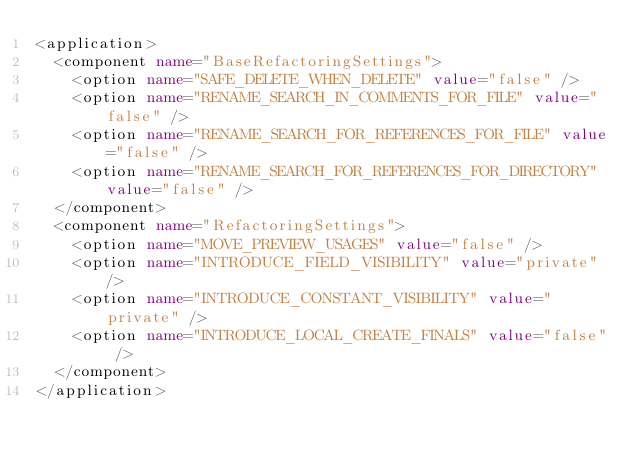Convert code to text. <code><loc_0><loc_0><loc_500><loc_500><_XML_><application>
  <component name="BaseRefactoringSettings">
    <option name="SAFE_DELETE_WHEN_DELETE" value="false" />
    <option name="RENAME_SEARCH_IN_COMMENTS_FOR_FILE" value="false" />
    <option name="RENAME_SEARCH_FOR_REFERENCES_FOR_FILE" value="false" />
    <option name="RENAME_SEARCH_FOR_REFERENCES_FOR_DIRECTORY" value="false" />
  </component>
  <component name="RefactoringSettings">
    <option name="MOVE_PREVIEW_USAGES" value="false" />
    <option name="INTRODUCE_FIELD_VISIBILITY" value="private" />
    <option name="INTRODUCE_CONSTANT_VISIBILITY" value="private" />
    <option name="INTRODUCE_LOCAL_CREATE_FINALS" value="false" />
  </component>
</application></code> 